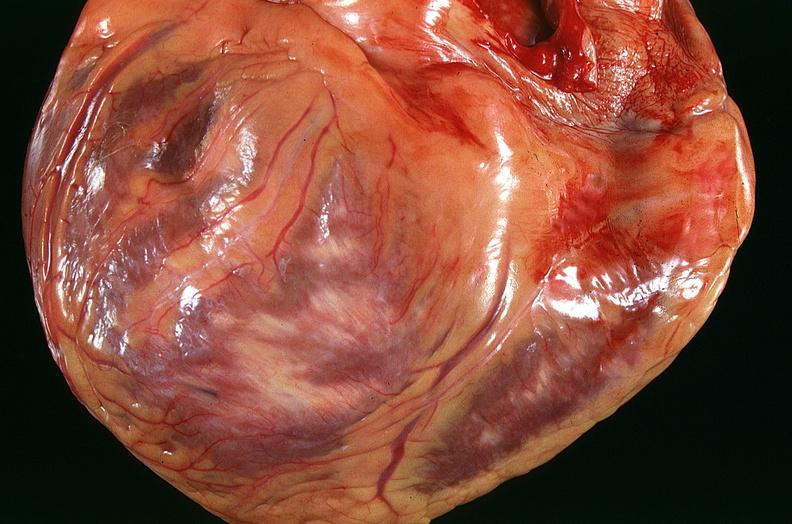s atrophy present?
Answer the question using a single word or phrase. No 